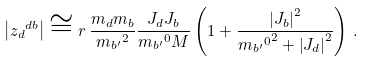Convert formula to latex. <formula><loc_0><loc_0><loc_500><loc_500>\left | { z _ { d } } ^ { d b } \right | \cong r \, \frac { m _ { d } m _ { b } } { { m _ { b ^ { \prime } } } ^ { 2 } } \frac { J _ { d } J _ { b } } { { m _ { b ^ { \prime } } } ^ { 0 } M } \left ( 1 + \frac { \left | J _ { b } \right | ^ { 2 } } { { { m _ { b ^ { \prime } } } ^ { 0 } } ^ { 2 } + \left | J _ { d } \right | ^ { 2 } } \right ) \, .</formula> 